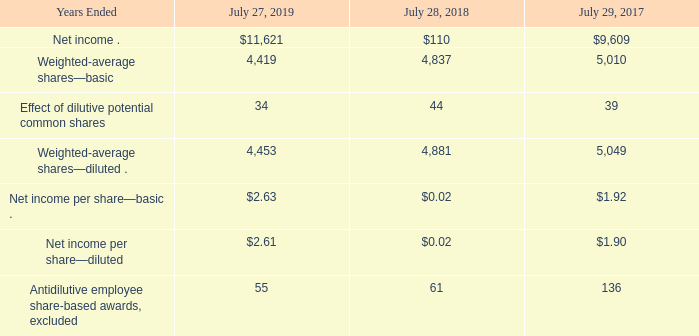19. Net Income per Share
The following table presents the calculation of basic and diluted net income per share (in millions, except per-share amounts):
Employee equity share options, unvested shares, and similar equity instruments granted and assumed by Cisco are treated as potential common shares outstanding in computing diluted earnings per share. Diluted shares outstanding include the dilutive effect of in-the-money options, unvested restricted stock, and restricted stock units. The dilutive effect of such equity awards is calculated based on the average share price for each fiscal period using the treasury stock method. Under the treasury stock method, the amount the employee must pay for exercising stock options and the amount of compensation cost for future service that has not yet recognized are collectively assumed to be used to repurchase shares.
What does diluted shares outstanding include? The dilutive effect of in-the-money options, unvested restricted stock, and restricted stock units. What was the basic weighted-average shares in 2019?
Answer scale should be: million. 4,419. What was the basic net income per share in 2018? 0.02. What was the change in the Effect of dilutive potential common shares between 2017 and 2018?
Answer scale should be: million. 44-39
Answer: 5. How many years did the basic weighted-average shares exceed $5,000 million? 2017
Answer: 1. What was the percentage change in net income between 2018 and 2019?
Answer scale should be: percent. (11,621-110)/110
Answer: 10464.55. 